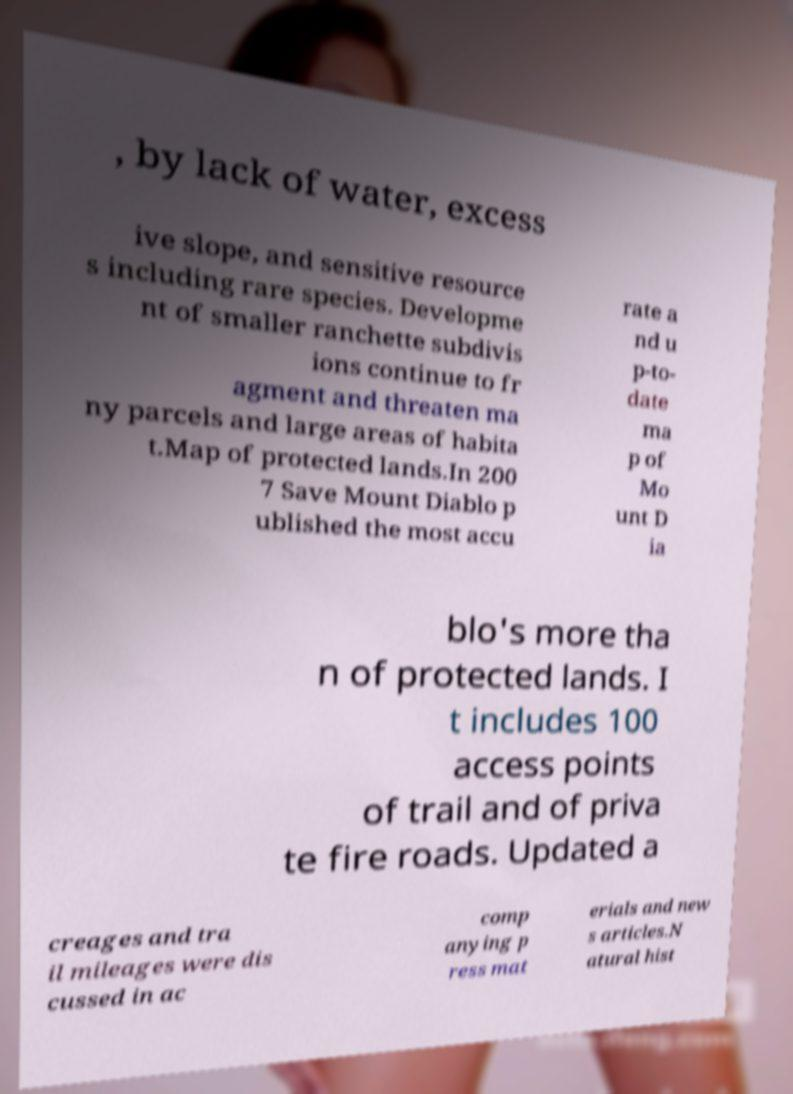Could you assist in decoding the text presented in this image and type it out clearly? , by lack of water, excess ive slope, and sensitive resource s including rare species. Developme nt of smaller ranchette subdivis ions continue to fr agment and threaten ma ny parcels and large areas of habita t.Map of protected lands.In 200 7 Save Mount Diablo p ublished the most accu rate a nd u p-to- date ma p of Mo unt D ia blo's more tha n of protected lands. I t includes 100 access points of trail and of priva te fire roads. Updated a creages and tra il mileages were dis cussed in ac comp anying p ress mat erials and new s articles.N atural hist 